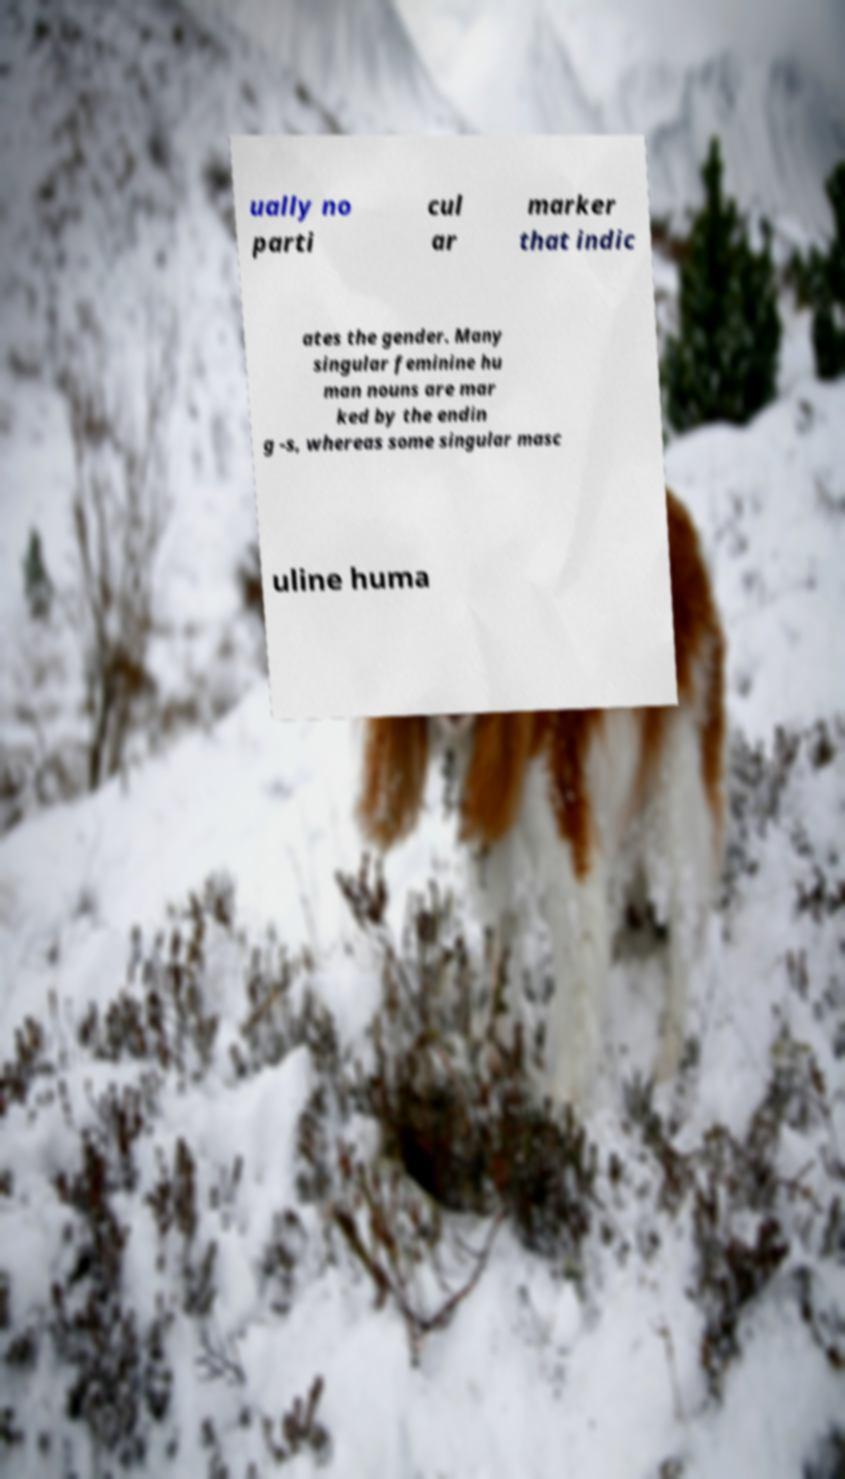There's text embedded in this image that I need extracted. Can you transcribe it verbatim? ually no parti cul ar marker that indic ates the gender. Many singular feminine hu man nouns are mar ked by the endin g -s, whereas some singular masc uline huma 